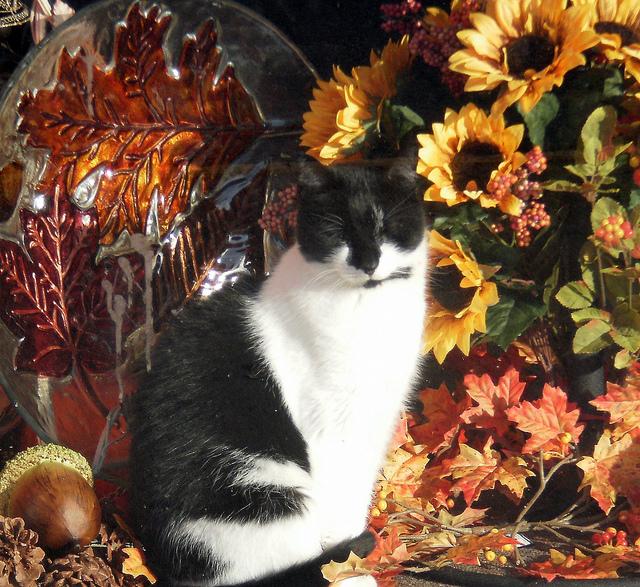What color is the cat?
Answer briefly. Black and white. Does this cat like flowers?
Short answer required. Yes. What kind of animal is this?
Be succinct. Cat. 